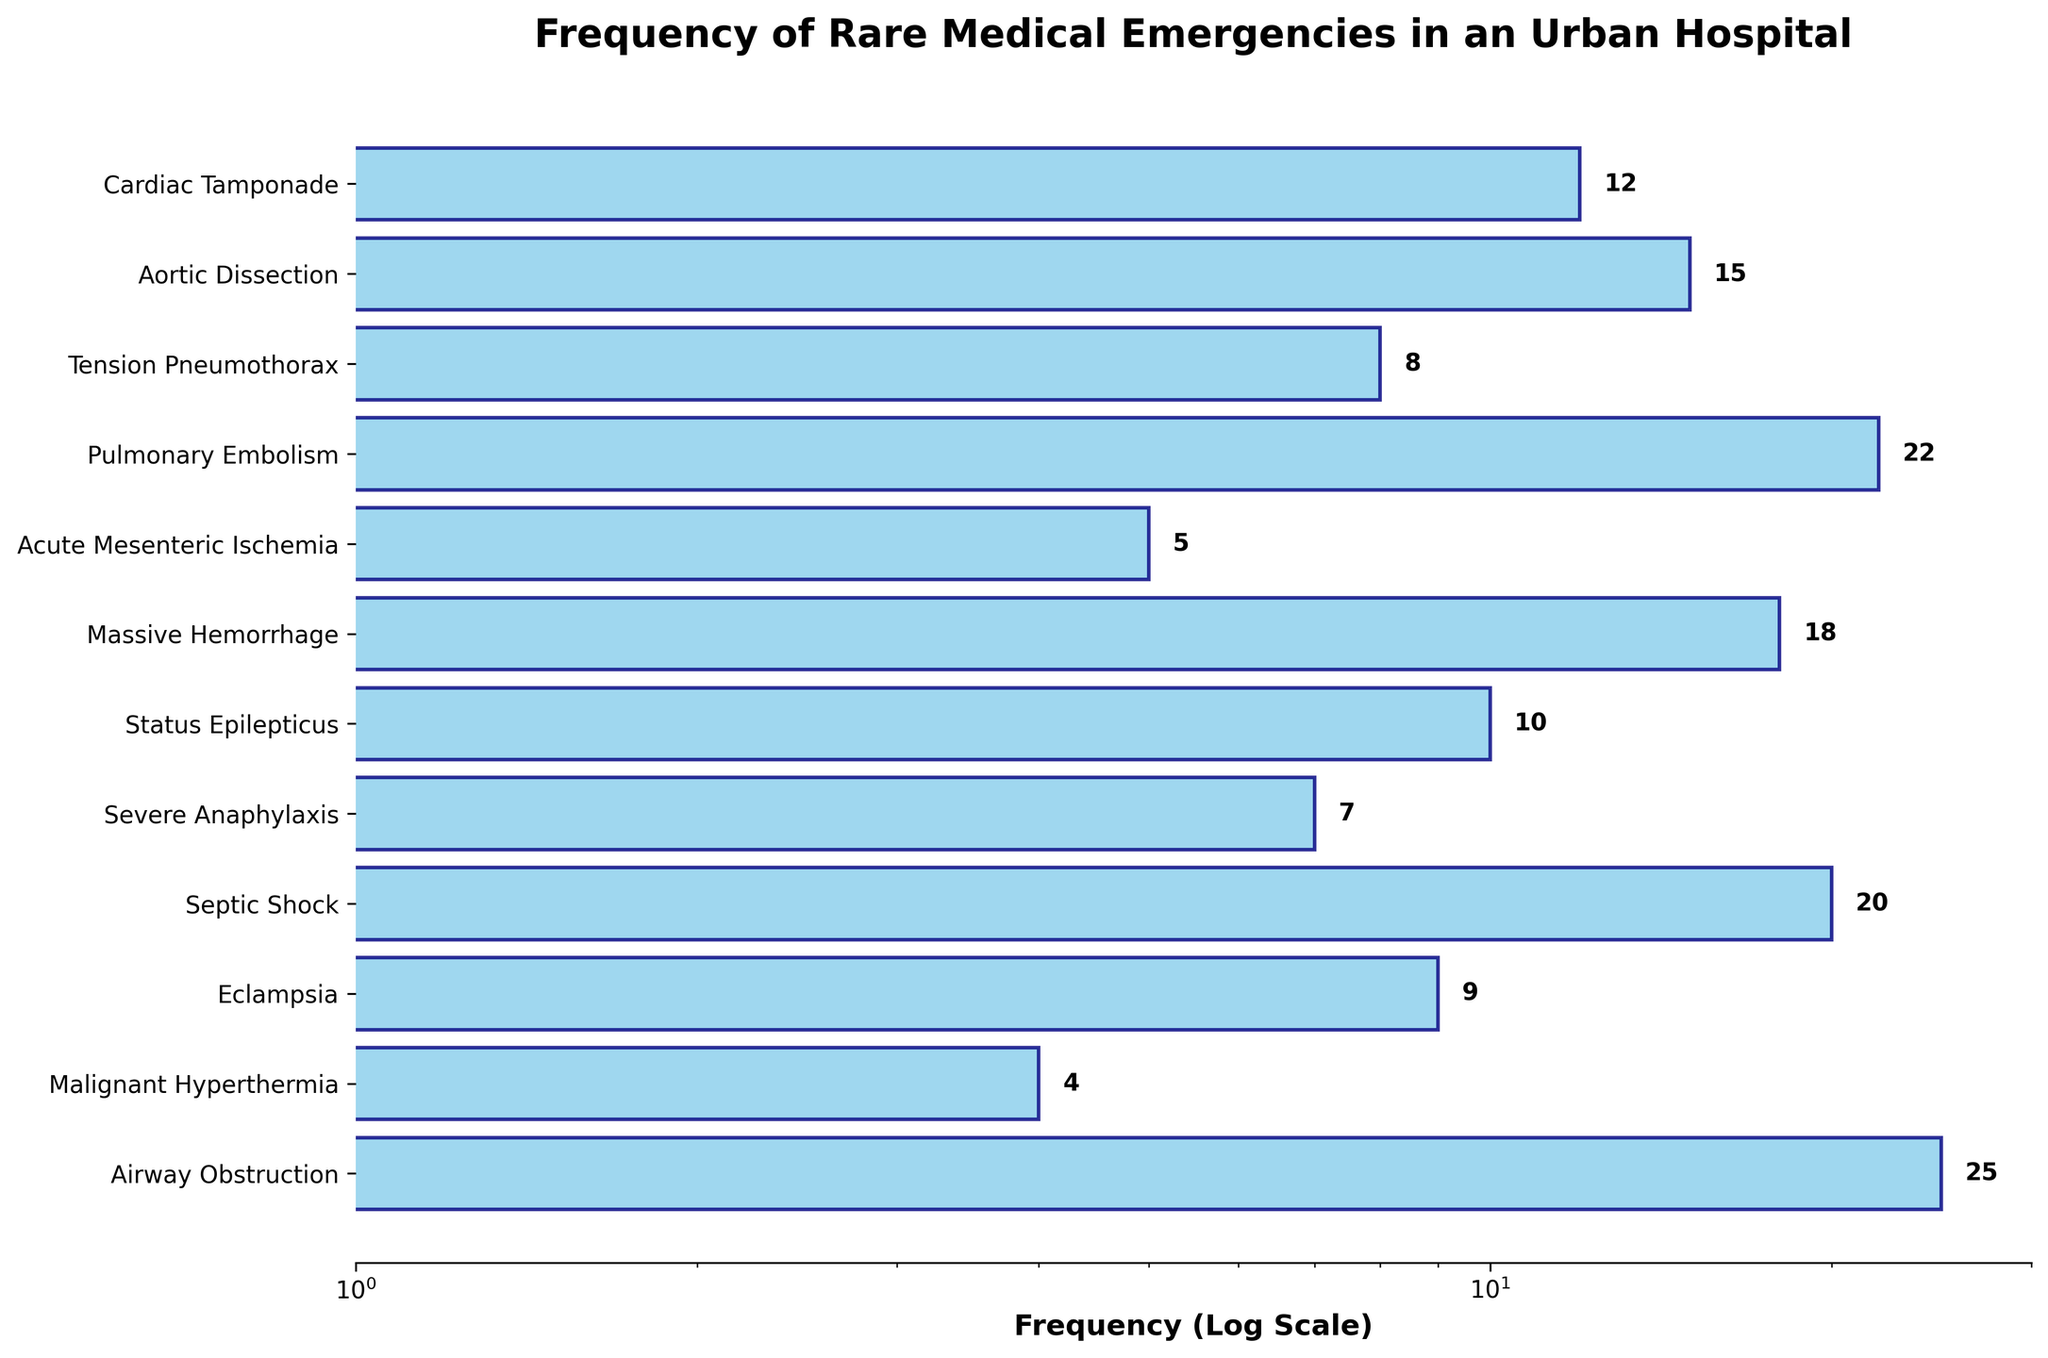Which emergency type has the highest frequency? The horizontal bar plot shows different types of emergencies on the y-axis and their frequencies on the x-axis (log scale). The longest bar indicates the highest frequency. The label corresponding to the longest bar is "Airway Obstruction".
Answer: Airway Obstruction What is the frequency of Malignant Hyperthermia? To find this, locate the "Malignant Hyperthermia" label on the y-axis and look at the length and value of the corresponding bar. The bar extends to the frequency value of 4.
Answer: 4 Which emergency type has the lowest frequency and what is that frequency? The shortest bar will indicate the lowest frequency. This bar corresponds to the "Malignant Hyperthermia" emergency type, which shows a frequency of 4.
Answer: Malignant Hyperthermia, 4 What is the total frequency of all rare medical emergencies combined? Sum up the individual frequencies of all the emergencies shown in the plot. Cardiac Tamponade (12) + Aortic Dissection (15) + Tension Pneumothorax (8) + Pulmonary Embolism (22) + Acute Mesenteric Ischemia (5) + Massive Hemorrhage (18) + Status Epilepticus (10) + Severe Anaphylaxis (7) + Septic Shock (20) + Eclampsia (9) + Malignant Hyperthermia (4) + Airway Obstruction (25). The total sum is 155.
Answer: 155 How many emergency types have frequencies greater than 15? Identify and count the bars that extend beyond the frequency mark of 15 on the log scale axis. These include "Aortic Dissection (15)" is not included, so only "Pulmonary Embolism (22)", "Massive Hemorrhage (18)", "Septic Shock (20)", and "Airway Obstruction (25)" are counted. The total count is 4.
Answer: 4 What is the median frequency of the emergency types? To find the median, arrange all the frequencies in ascending order: 4, 5, 7, 8, 9, 10, 12, 15, 18, 20, 22, 25. Since there are 12 values, the median will be the average of the 6th and 7th values: (10 + 12) / 2 = 11.
Answer: 11 How many bars have frequencies less than 10? Count the bars whose lengths end before the 10 tick mark. These include "Tension Pneumothorax", "Acute Mesenteric Ischemia", "Severe Anaphylaxis", "Eclampsia", and "Malignant Hyperthermia". The total count is 5.
Answer: 5 What is the approximate frequency range displayed in the chart? The smallest frequency is 4 (Malignant Hyperthermia) and the largest frequency is 25 (Airway Obstruction). Hence, the range is 25 - 4 = 21.
Answer: 21 